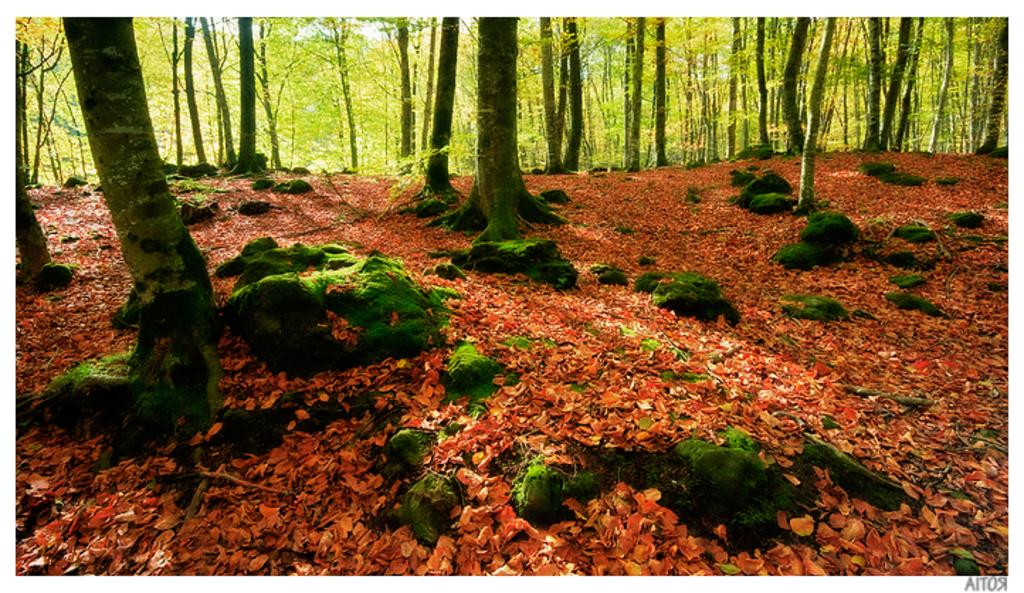What type of natural environment is depicted in the image? The image contains a forest. What are the main features of the forest? There are trees in the forest. Are there any other elements visible in the forest? Yes, stones are visible in the forest. What can be seen at the bottom of the image? Leaves are visible at the bottom of the image. What type of pipe can be seen running through the forest in the image? There is no pipe visible in the image; it only contains a forest with trees, stones, and leaves. 